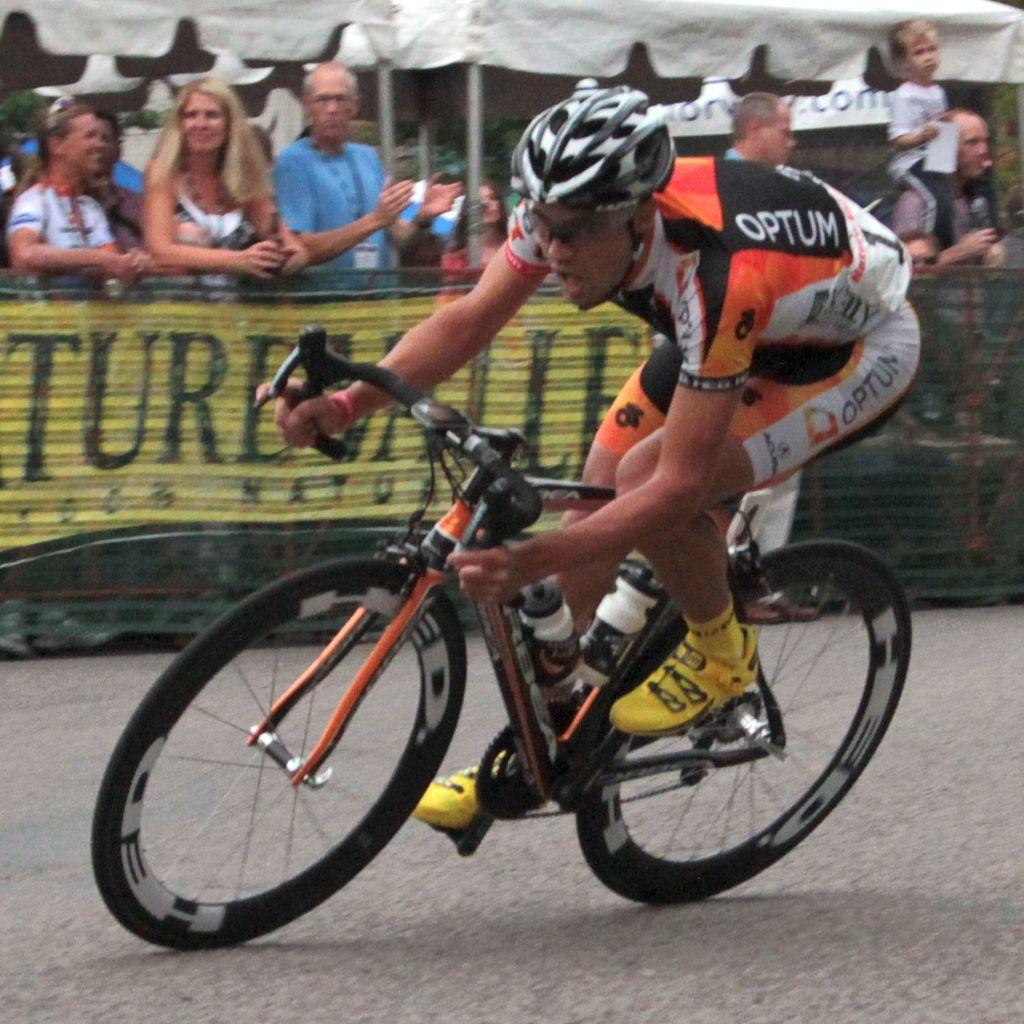Who is the main subject in the image? There is a person in the image. What is the person wearing? The person is wearing an orange dress. What activity is the person engaged in? The person is riding a bicycle. Are there any other people present in the image? Yes, there are people standing beside the person riding the bicycle. What book is the person reading while riding the bicycle? There is no book or reading activity present in the image; the person is riding a bicycle while wearing an orange dress. 